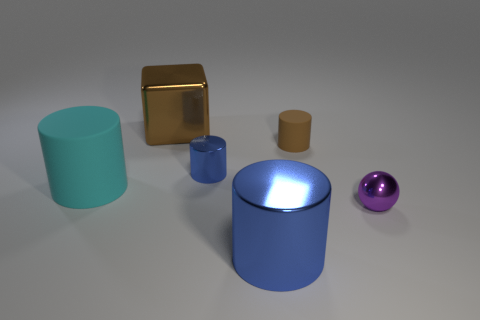Are there any other things that have the same shape as the tiny purple shiny thing?
Provide a short and direct response. No. How many blue metallic things have the same size as the purple metal object?
Your response must be concise. 1. How many objects are big cylinders in front of the purple metal sphere or small cylinders in front of the brown cylinder?
Give a very brief answer. 2. Do the big cylinder behind the ball and the brown object to the left of the small matte cylinder have the same material?
Ensure brevity in your answer.  No. The small metal object that is on the right side of the small shiny object on the left side of the tiny brown cylinder is what shape?
Provide a succinct answer. Sphere. Is there any other thing of the same color as the tiny shiny ball?
Make the answer very short. No. Is there a thing on the right side of the brown object to the left of the large thing in front of the small purple metal sphere?
Make the answer very short. Yes. Is the color of the matte cylinder to the left of the tiny blue thing the same as the rubber cylinder on the right side of the large brown metallic cube?
Offer a terse response. No. What is the material of the cyan cylinder that is the same size as the brown metallic thing?
Make the answer very short. Rubber. There is a matte cylinder that is on the left side of the metallic cylinder that is in front of the matte cylinder that is to the left of the brown metallic cube; what is its size?
Give a very brief answer. Large. 